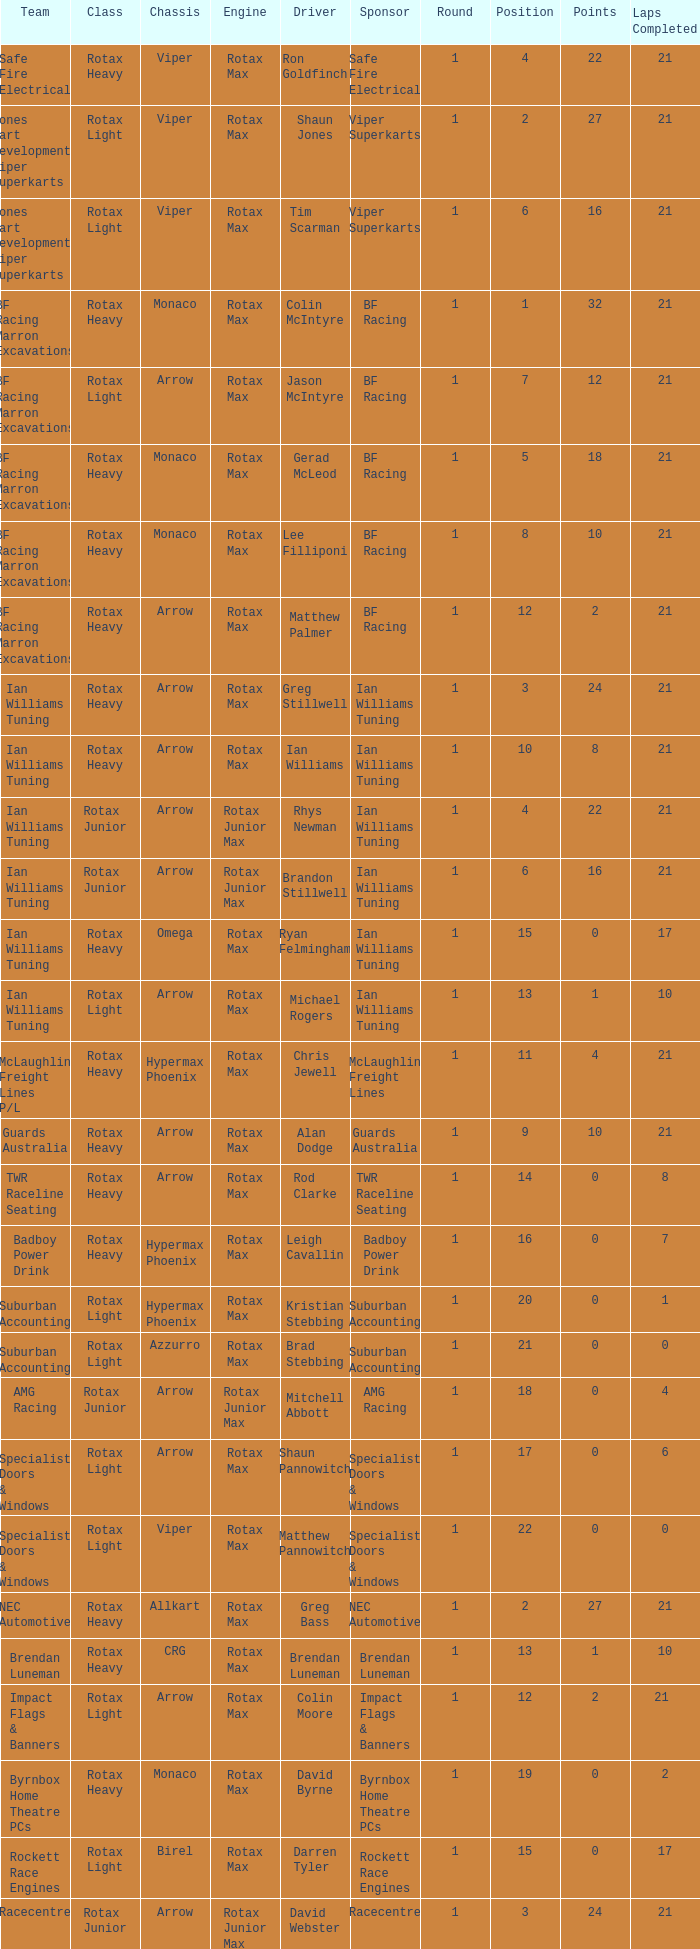Which team does Colin Moore drive for? Impact Flags & Banners. 